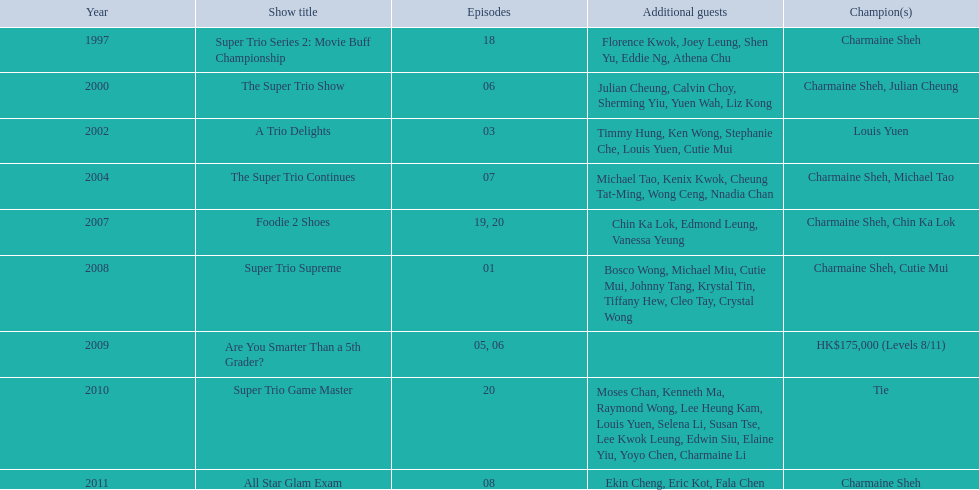How many times has charmaine sheh won on a variety show? 6. Can you give me this table as a dict? {'header': ['Year', 'Show title', 'Episodes', 'Additional guests', 'Champion(s)'], 'rows': [['1997', 'Super Trio Series 2: Movie Buff Championship', '18', 'Florence Kwok, Joey Leung, Shen Yu, Eddie Ng, Athena Chu', 'Charmaine Sheh'], ['2000', 'The Super Trio Show', '06', 'Julian Cheung, Calvin Choy, Sherming Yiu, Yuen Wah, Liz Kong', 'Charmaine Sheh, Julian Cheung'], ['2002', 'A Trio Delights', '03', 'Timmy Hung, Ken Wong, Stephanie Che, Louis Yuen, Cutie Mui', 'Louis Yuen'], ['2004', 'The Super Trio Continues', '07', 'Michael Tao, Kenix Kwok, Cheung Tat-Ming, Wong Ceng, Nnadia Chan', 'Charmaine Sheh, Michael Tao'], ['2007', 'Foodie 2 Shoes', '19, 20', 'Chin Ka Lok, Edmond Leung, Vanessa Yeung', 'Charmaine Sheh, Chin Ka Lok'], ['2008', 'Super Trio Supreme', '01', 'Bosco Wong, Michael Miu, Cutie Mui, Johnny Tang, Krystal Tin, Tiffany Hew, Cleo Tay, Crystal Wong', 'Charmaine Sheh, Cutie Mui'], ['2009', 'Are You Smarter Than a 5th Grader?', '05, 06', '', 'HK$175,000 (Levels 8/11)'], ['2010', 'Super Trio Game Master', '20', 'Moses Chan, Kenneth Ma, Raymond Wong, Lee Heung Kam, Louis Yuen, Selena Li, Susan Tse, Lee Kwok Leung, Edwin Siu, Elaine Yiu, Yoyo Chen, Charmaine Li', 'Tie'], ['2011', 'All Star Glam Exam', '08', 'Ekin Cheng, Eric Kot, Fala Chen', 'Charmaine Sheh']]} 